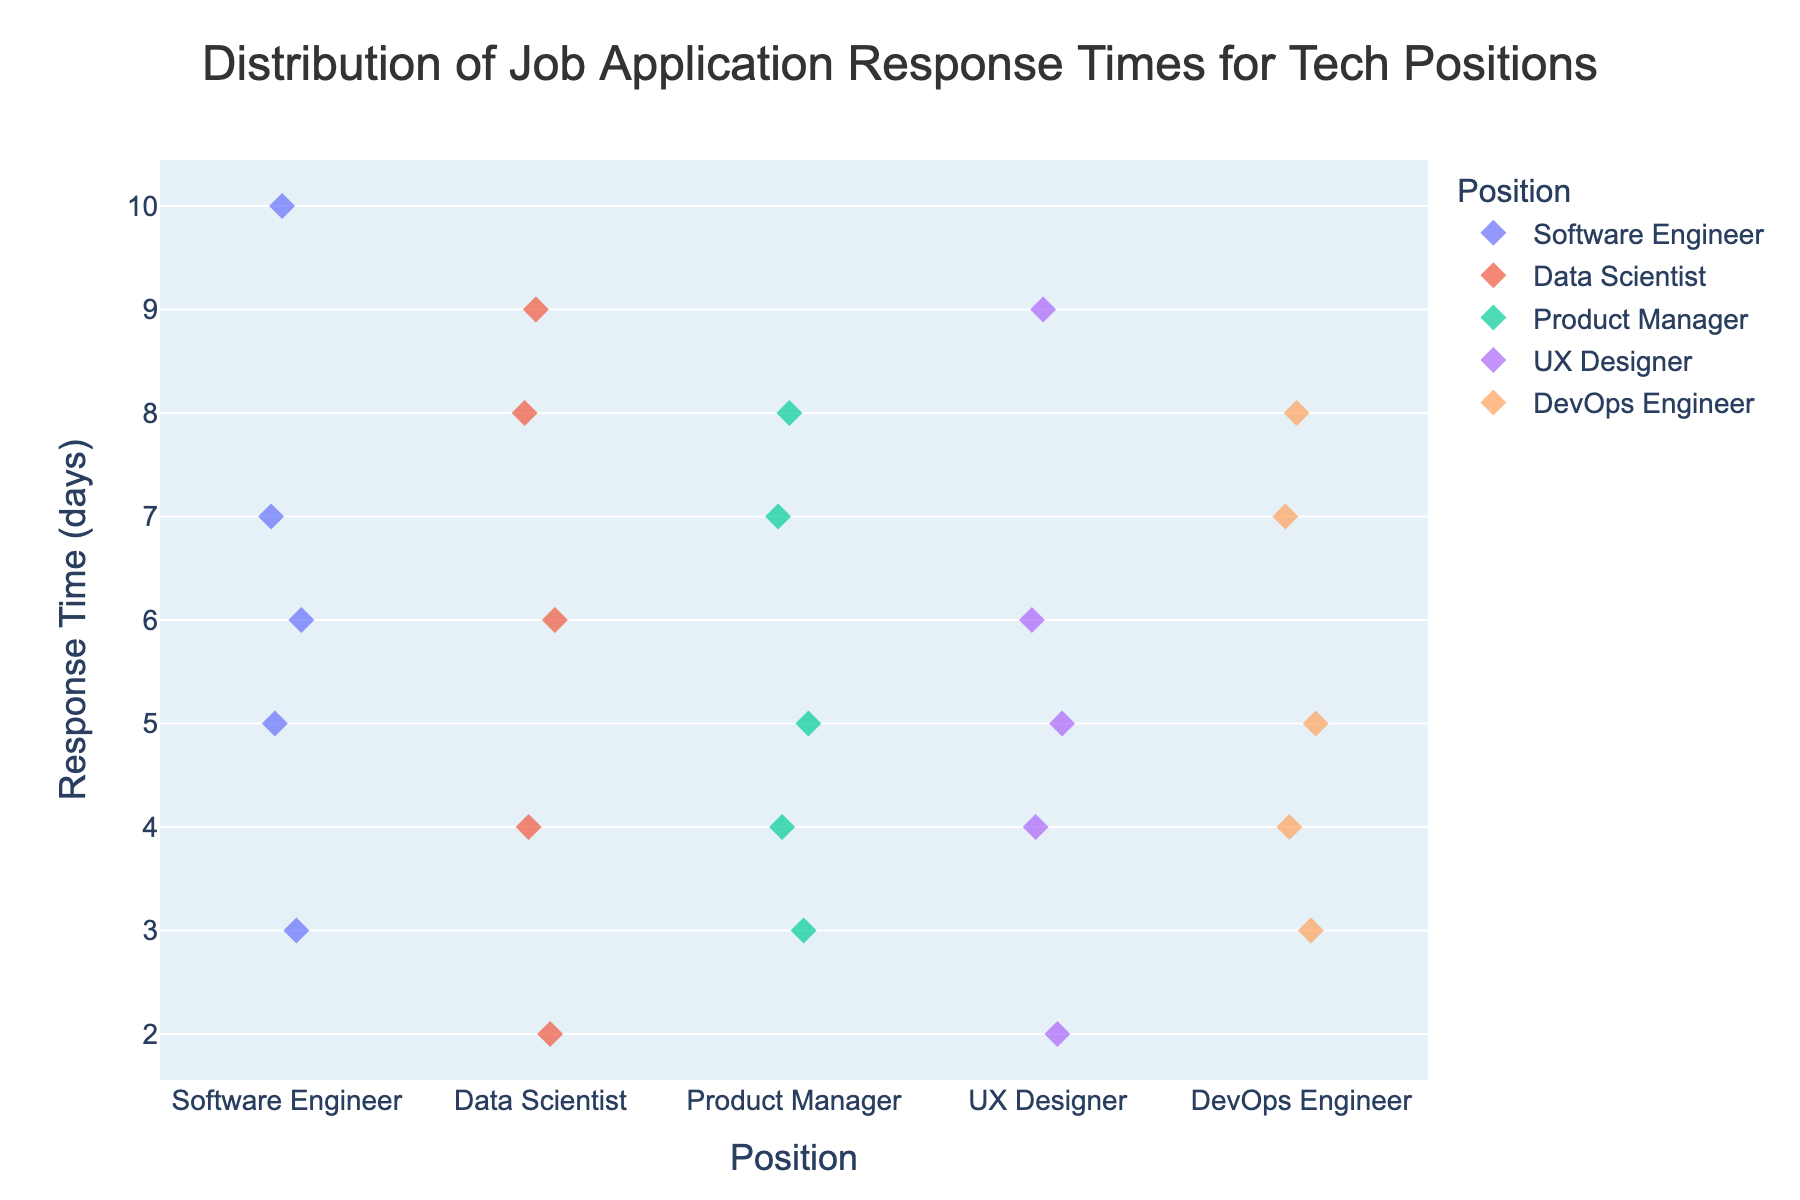what positions are shown in the plot? The x-axis of the strip plot displays different tech positions. Observing the x-axis, we can see the positions labeled.
Answer: Software Engineer, Data Scientist, Product Manager, UX Designer, DevOps Engineer what is the range of response times for Data Scientists? The y-axis represents response times in days, and by looking at the points for Data Scientists on the graph, we can determine the minimum and maximum values. The range spans from the lowest point (2 days) to the highest point (9 days).
Answer: 2 - 9 days which tech position has the smallest range of response times? By examining the spread of points along the y-axis for each position, we can determine which position has the least variation. Product Managers have response times ranging from 3 to 8 days, which is the smallest range compared to other positions.
Answer: Product Manager What is the median response time for Software Engineers? To find the median, we list the response times in ascending order (3, 5, 6, 7, 10) and pick the middle value. The third value in this ordered set is the median.
Answer: 6 Are there any positions with identical maximum response times? By looking at the highest points of each strip plot, we observe the maximum response times. Both Data Scientists and UX Designers have maximum response times of 9 days.
Answer: Yes, Data Scientist and UX Designer Which position has the highest single response time? View the y-axis to find the highest point on the plot, identifying the position corresponding to this point.
Answer: Software Engineer (10 days) How does the distribution of response times for UX Designers compare to Software Engineers? Compare the spread and concentration of points between the two positions. UX Designers’ response times are more spread out (2 to 9 days), whereas Software Engineers have a slightly narrower spread (3 to 10 days), but both show similar variability.
Answer: Both show high variability, but Software Engineers have a slightly wider range What is the average response time for DevOps Engineers? List and sum DevOps Engineers' response times (3, 4, 5, 7, 8). The sum is 27, and there are 5 data points. The average is calculated by dividing the sum by 5.
Answer: 5.4 days Does any position have a lower minimum response time than Data Scientists? By checking each position’s lower bound on the y-axis, we see that both Data Scientists and UX Designers have the lowest minimum at 2 days. No position has a lower minimum.
Answer: No 